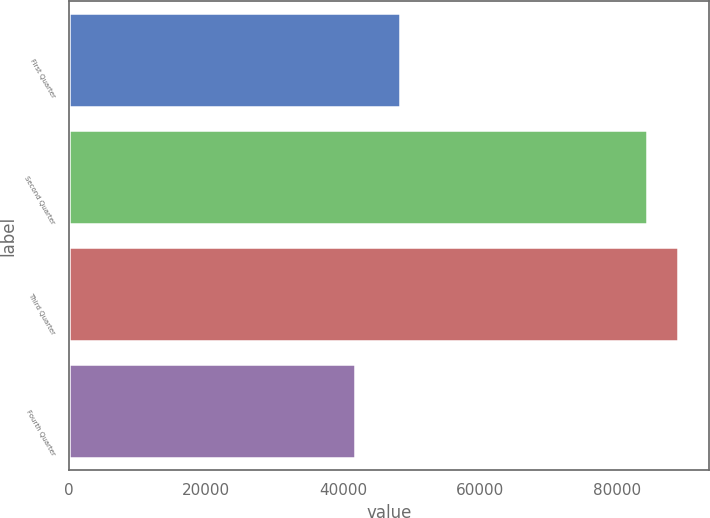<chart> <loc_0><loc_0><loc_500><loc_500><bar_chart><fcel>First Quarter<fcel>Second Quarter<fcel>Third Quarter<fcel>Fourth Quarter<nl><fcel>48318<fcel>84357<fcel>88899<fcel>41710<nl></chart> 